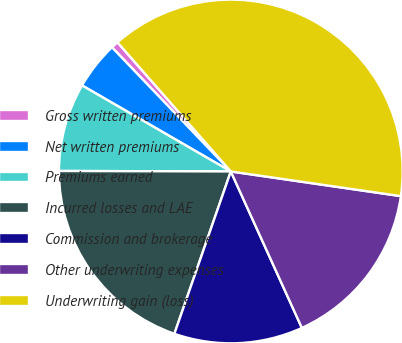Convert chart. <chart><loc_0><loc_0><loc_500><loc_500><pie_chart><fcel>Gross written premiums<fcel>Net written premiums<fcel>Premiums earned<fcel>Incurred losses and LAE<fcel>Commission and brokerage<fcel>Other underwriting expenses<fcel>Underwriting gain (loss)<nl><fcel>0.69%<fcel>4.5%<fcel>8.3%<fcel>19.72%<fcel>12.11%<fcel>15.92%<fcel>38.76%<nl></chart> 